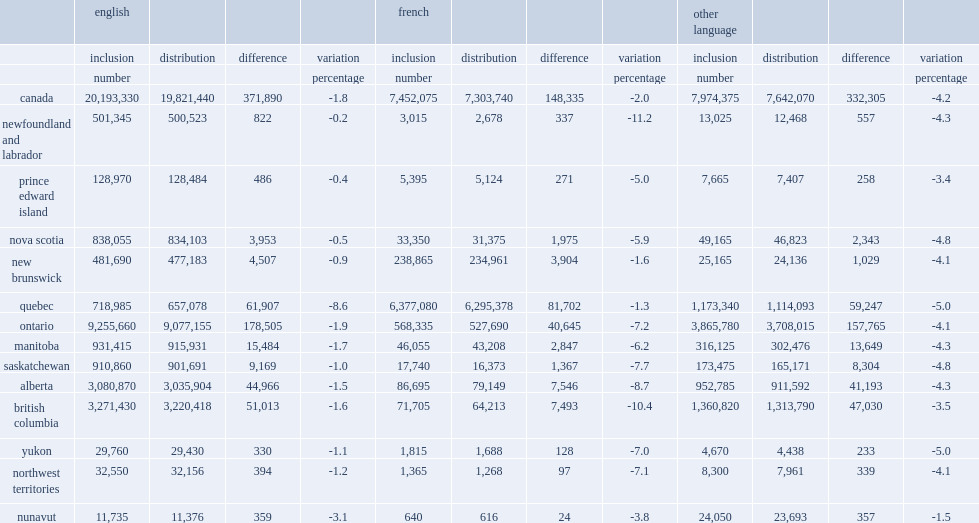What were the differences translate to respondents whose mother tongue is english,french and a language other than english or french in numbers,respectively? 371890.0 148335.0 332305.0. In quebec, what was the difference of respondents who reported english as their mother tongue from the english mother tongue group in number? 61907.0. What were the percentages of variation of respondents who reported french as their mother tongue in newfoundland and labrador and those in british columbia respectively? 11.2 10.4. Can you give me this table as a dict? {'header': ['', 'english', '', '', '', 'french', '', '', '', 'other language', '', '', ''], 'rows': [['', 'inclusion', 'distribution', 'difference', 'variation', 'inclusion', 'distribution', 'difference', 'variation', 'inclusion', 'distribution', 'difference', 'variation'], ['', 'number', '', '', 'percentage', 'number', '', '', 'percentage', 'number', '', '', 'percentage'], ['canada', '20,193,330', '19,821,440', '371,890', '-1.8', '7,452,075', '7,303,740', '148,335', '-2.0', '7,974,375', '7,642,070', '332,305', '-4.2'], ['newfoundland and labrador', '501,345', '500,523', '822', '-0.2', '3,015', '2,678', '337', '-11.2', '13,025', '12,468', '557', '-4.3'], ['prince edward island', '128,970', '128,484', '486', '-0.4', '5,395', '5,124', '271', '-5.0', '7,665', '7,407', '258', '-3.4'], ['nova scotia', '838,055', '834,103', '3,953', '-0.5', '33,350', '31,375', '1,975', '-5.9', '49,165', '46,823', '2,343', '-4.8'], ['new brunswick', '481,690', '477,183', '4,507', '-0.9', '238,865', '234,961', '3,904', '-1.6', '25,165', '24,136', '1,029', '-4.1'], ['quebec', '718,985', '657,078', '61,907', '-8.6', '6,377,080', '6,295,378', '81,702', '-1.3', '1,173,340', '1,114,093', '59,247', '-5.0'], ['ontario', '9,255,660', '9,077,155', '178,505', '-1.9', '568,335', '527,690', '40,645', '-7.2', '3,865,780', '3,708,015', '157,765', '-4.1'], ['manitoba', '931,415', '915,931', '15,484', '-1.7', '46,055', '43,208', '2,847', '-6.2', '316,125', '302,476', '13,649', '-4.3'], ['saskatchewan', '910,860', '901,691', '9,169', '-1.0', '17,740', '16,373', '1,367', '-7.7', '173,475', '165,171', '8,304', '-4.8'], ['alberta', '3,080,870', '3,035,904', '44,966', '-1.5', '86,695', '79,149', '7,546', '-8.7', '952,785', '911,592', '41,193', '-4.3'], ['british columbia', '3,271,430', '3,220,418', '51,013', '-1.6', '71,705', '64,213', '7,493', '-10.4', '1,360,820', '1,313,790', '47,030', '-3.5'], ['yukon', '29,760', '29,430', '330', '-1.1', '1,815', '1,688', '128', '-7.0', '4,670', '4,438', '233', '-5.0'], ['northwest territories', '32,550', '32,156', '394', '-1.2', '1,365', '1,268', '97', '-7.1', '8,300', '7,961', '339', '-4.1'], ['nunavut', '11,735', '11,376', '359', '-3.1', '640', '616', '24', '-3.8', '24,050', '23,693', '357', '-1.5']]} 